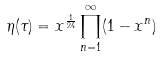Convert formula to latex. <formula><loc_0><loc_0><loc_500><loc_500>\eta ( \tau ) = x ^ { \frac { 1 } { 2 4 } } \prod _ { n = 1 } ^ { \infty } ( 1 - x ^ { n } )</formula> 